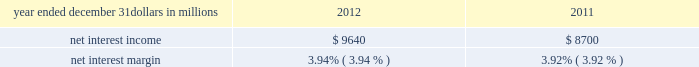Consolidated income statement review our consolidated income statement is presented in item 8 of this report .
Net income for 2012 was $ 3.0 billion compared with $ 3.1 billion for 2011 .
Revenue growth of 8 percent and a decline in the provision for credit losses were more than offset by a 16 percent increase in noninterest expense in 2012 compared to 2011 .
Further detail is included in the net interest income , noninterest income , provision for credit losses and noninterest expense portions of this consolidated income statement review .
Net interest income table 2 : net interest income and net interest margin year ended december 31 dollars in millions 2012 2011 .
Changes in net interest income and margin result from the interaction of the volume and composition of interest-earning assets and related yields , interest-bearing liabilities and related rates paid , and noninterest-bearing sources of funding .
See the statistical information ( unaudited ) 2013 average consolidated balance sheet and net interest analysis and analysis of year-to-year changes in net interest income in item 8 of this report and the discussion of purchase accounting accretion of purchased impaired loans in the consolidated balance sheet review in this item 7 for additional information .
The increase in net interest income in 2012 compared with 2011 was primarily due to the impact of the rbc bank ( usa ) acquisition , organic loan growth and lower funding costs .
Purchase accounting accretion remained stable at $ 1.1 billion in both periods .
The net interest margin was 3.94% ( 3.94 % ) for 2012 and 3.92% ( 3.92 % ) for 2011 .
The increase in the comparison was primarily due to a decrease in the weighted-average rate accrued on total interest- bearing liabilities of 29 basis points , largely offset by a 21 basis point decrease on the yield on total interest-earning assets .
The decrease in the rate on interest-bearing liabilities was primarily due to the runoff of maturing retail certificates of deposit and the redemption of additional trust preferred and hybrid capital securities during 2012 , in addition to an increase in fhlb borrowings and commercial paper as lower-cost funding sources .
The decrease in the yield on interest-earning assets was primarily due to lower rates on new loan volume and lower yields on new securities in the current low rate environment .
With respect to the first quarter of 2013 , we expect net interest income to decline by two to three percent compared to fourth quarter 2012 net interest income of $ 2.4 billion , due to a decrease in purchase accounting accretion of up to $ 50 to $ 60 million , including lower expected cash recoveries .
For the full year 2013 , we expect net interest income to decrease compared with 2012 , assuming an expected decline in purchase accounting accretion of approximately $ 400 million , while core net interest income is expected to increase in the year-over-year comparison .
We believe our net interest margin will come under pressure in 2013 , due to the expected decline in purchase accounting accretion and assuming that the current low rate environment continues .
Noninterest income noninterest income totaled $ 5.9 billion for 2012 and $ 5.6 billion for 2011 .
The overall increase in the comparison was primarily due to an increase in residential mortgage loan sales revenue driven by higher loan origination volume , gains on sales of visa class b common shares and higher corporate service fees , largely offset by higher provision for residential mortgage repurchase obligations .
Asset management revenue , including blackrock , totaled $ 1.2 billion in 2012 compared with $ 1.1 billion in 2011 .
This increase was primarily due to higher earnings from our blackrock investment .
Discretionary assets under management increased to $ 112 billion at december 31 , 2012 compared with $ 107 billion at december 31 , 2011 driven by stronger average equity markets , positive net flows and strong sales performance .
For 2012 , consumer services fees were $ 1.1 billion compared with $ 1.2 billion in 2011 .
The decline reflected the regulatory impact of lower interchange fees on debit card transactions partially offset by customer growth .
As further discussed in the retail banking portion of the business segments review section of this item 7 , the dodd-frank limits on interchange rates were effective october 1 , 2011 and had a negative impact on revenue of approximately $ 314 million in 2012 and $ 75 million in 2011 .
This impact was partially offset by higher volumes of merchant , customer credit card and debit card transactions and the impact of the rbc bank ( usa ) acquisition .
Corporate services revenue increased by $ .3 billion , or 30 percent , to $ 1.2 billion in 2012 compared with $ .9 billion in 2011 due to higher commercial mortgage servicing revenue and higher merger and acquisition advisory fees in 2012 .
The major components of corporate services revenue are treasury management revenue , corporate finance fees , including revenue from capital markets-related products and services , and commercial mortgage servicing revenue , including commercial mortgage banking activities .
See the product revenue portion of this consolidated income statement review for further detail .
The pnc financial services group , inc .
2013 form 10-k 39 .
Dodd-frank was responsible for what time negative impact , in millions , on revenue in 2011 and 2012? 
Computations: (314 + 75)
Answer: 389.0. 